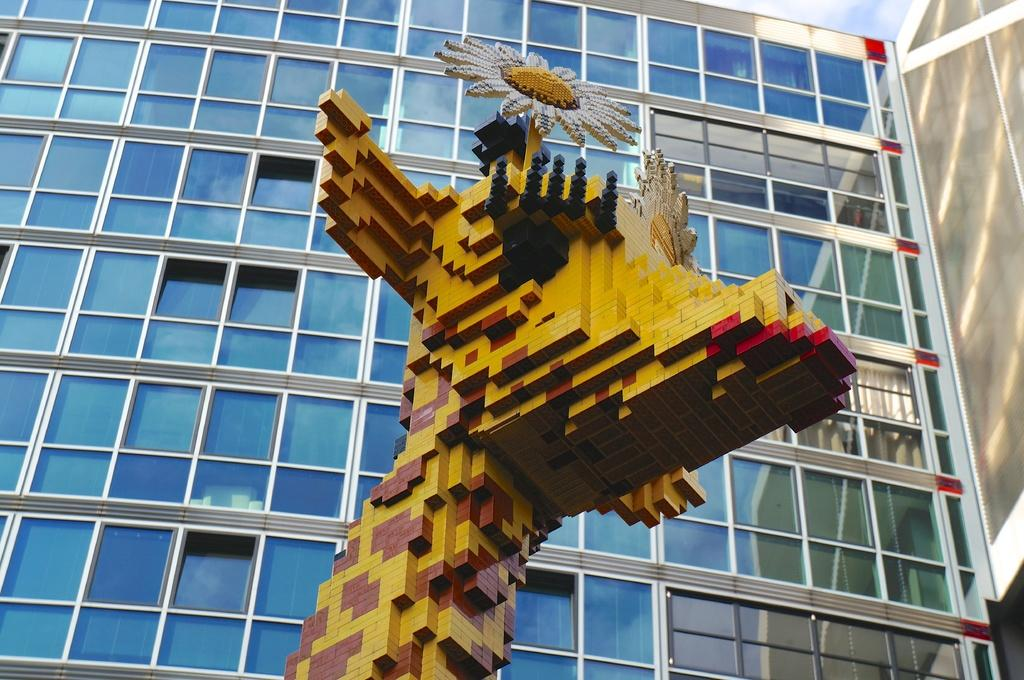What is the main subject of the image? The main subject of the image is a statue made up of Lego boards. What can be seen in the background of the image? There is a building with glass doors in the background of the image. What is visible in the sky in the image? The sky is visible in the background of the image. What type of bait is being used by the fisherman in the image? There is no fisherman or bait present in the image; it features a Lego statue and a building with glass doors. What color is the hose used by the firefighter in the image? There is no hose or firefighter present in the image; it features a Lego statue and a building with glass doors. 